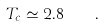<formula> <loc_0><loc_0><loc_500><loc_500>T _ { c } \simeq 2 . 8 \quad .</formula> 